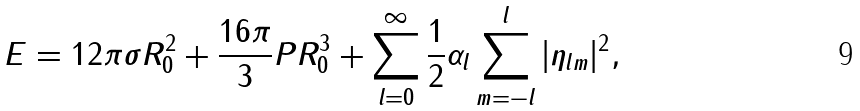<formula> <loc_0><loc_0><loc_500><loc_500>E = 1 2 \pi \sigma R _ { 0 } ^ { 2 } + \frac { 1 6 \pi } { 3 } P R _ { 0 } ^ { 3 } + \sum _ { l = 0 } ^ { \infty } \frac { 1 } { 2 } \alpha _ { l } \sum _ { m = - l } ^ { l } | \eta _ { l m } | ^ { 2 } ,</formula> 